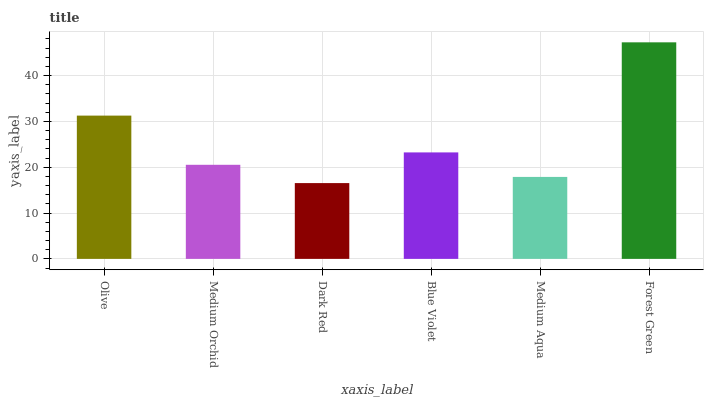Is Dark Red the minimum?
Answer yes or no. Yes. Is Forest Green the maximum?
Answer yes or no. Yes. Is Medium Orchid the minimum?
Answer yes or no. No. Is Medium Orchid the maximum?
Answer yes or no. No. Is Olive greater than Medium Orchid?
Answer yes or no. Yes. Is Medium Orchid less than Olive?
Answer yes or no. Yes. Is Medium Orchid greater than Olive?
Answer yes or no. No. Is Olive less than Medium Orchid?
Answer yes or no. No. Is Blue Violet the high median?
Answer yes or no. Yes. Is Medium Orchid the low median?
Answer yes or no. Yes. Is Dark Red the high median?
Answer yes or no. No. Is Forest Green the low median?
Answer yes or no. No. 